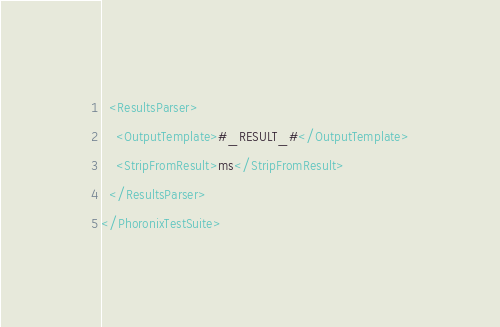<code> <loc_0><loc_0><loc_500><loc_500><_XML_>  <ResultsParser>
    <OutputTemplate>#_RESULT_#</OutputTemplate>
    <StripFromResult>ms</StripFromResult>
  </ResultsParser>
</PhoronixTestSuite>
</code> 